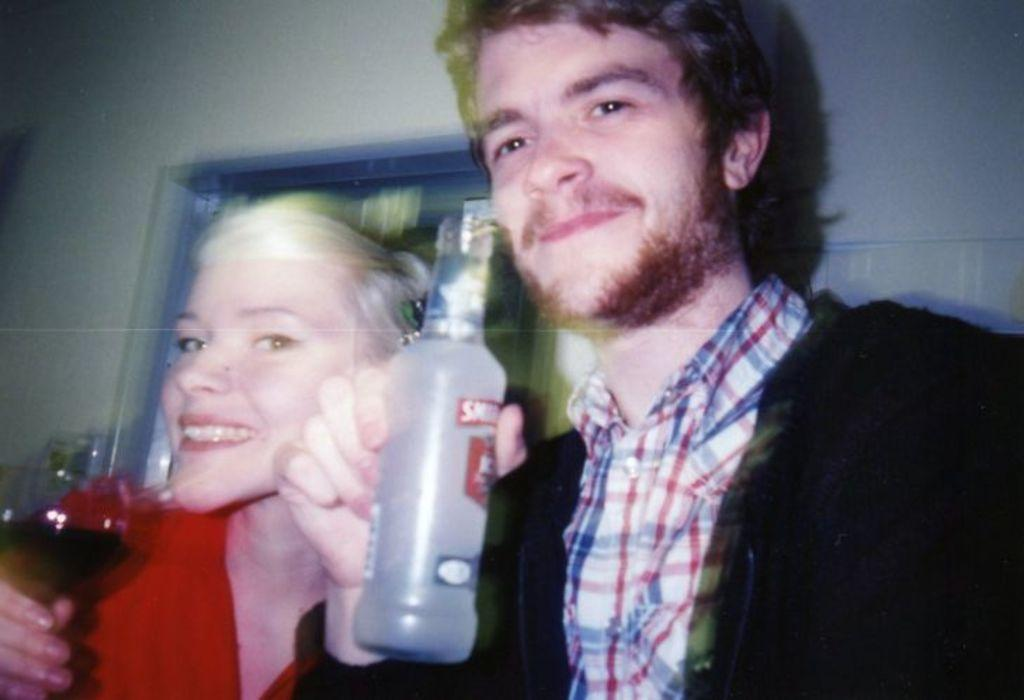Who is present in the image? There is a couple in the image. What is the emotional expression of the couple? Both individuals in the couple are smiling. What can be seen in the background of the image? There is a wall in the background of the image. What type of celery is the couple holding in the image? There is no celery present in the image. What type of throne is the couple sitting on in the image? There is no throne present in the image; the couple is standing. 